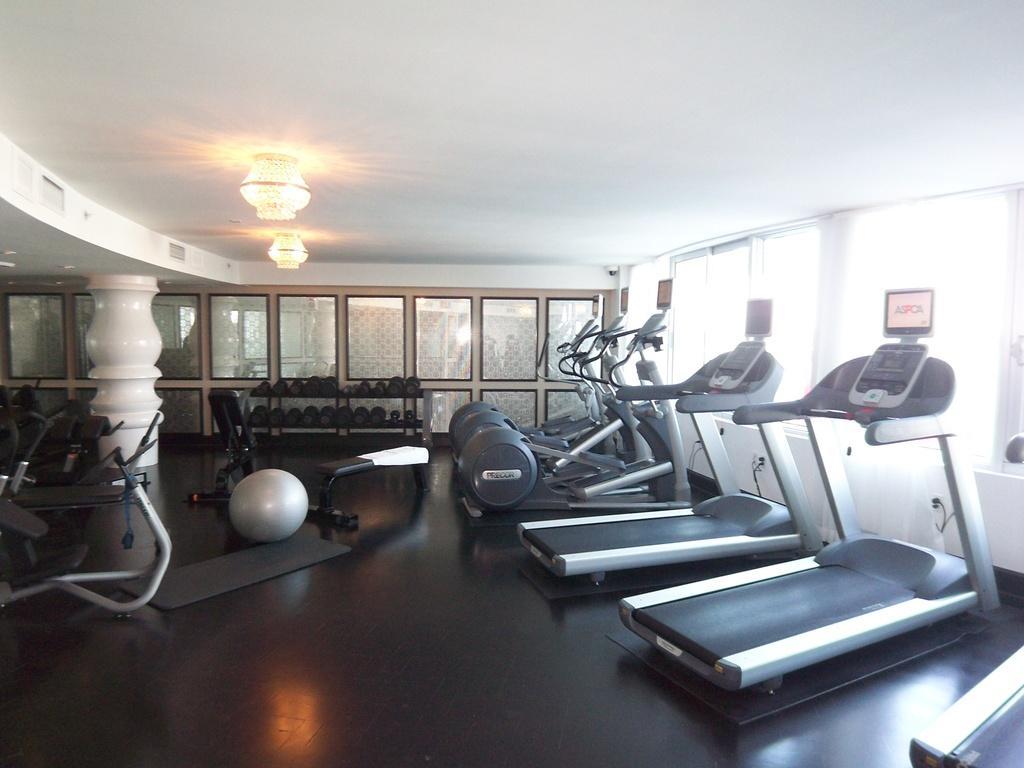Can you describe this image briefly? This picture is taken in a gym center having treadmills, ball and few dumbbells in the racks. There is a pillar at the left side of image. Few lights are attached to the roof. 